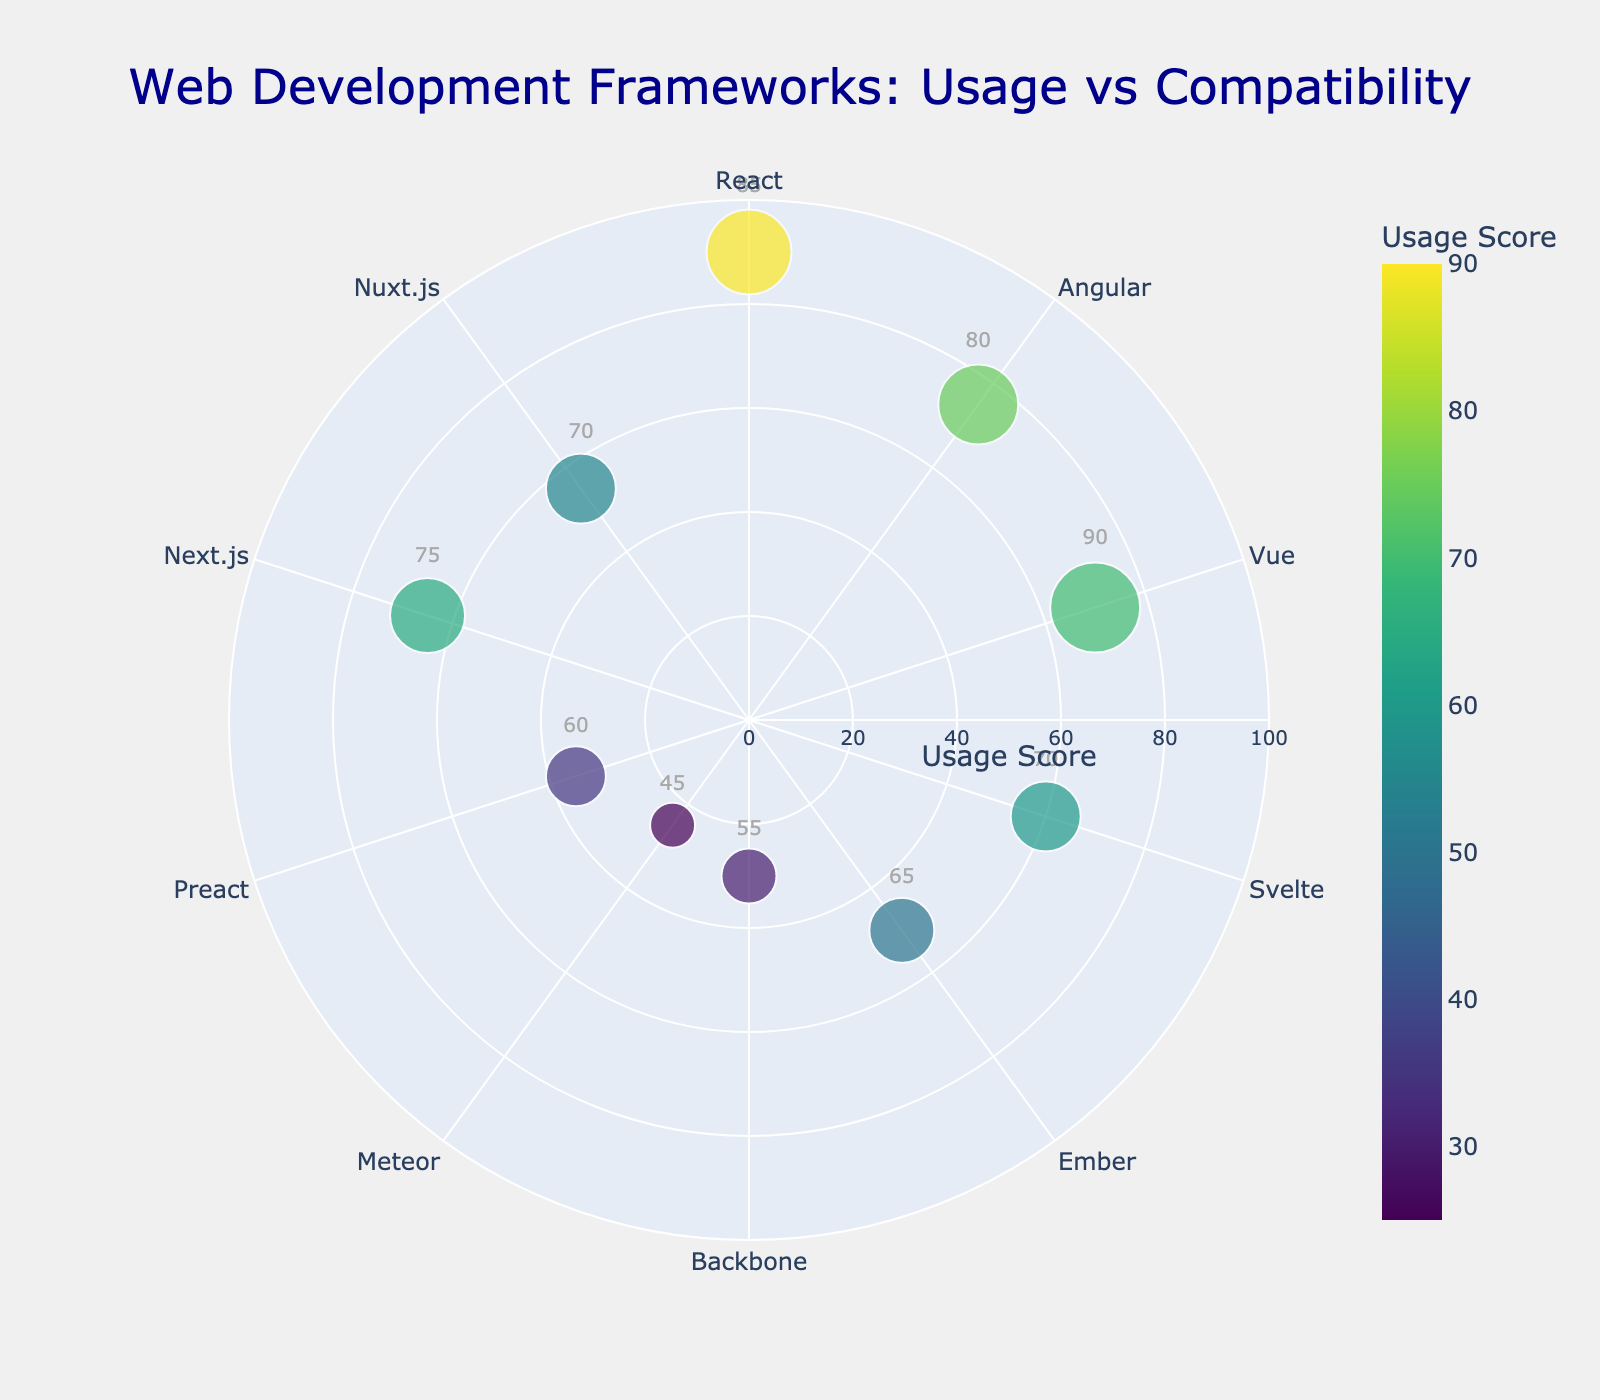Which framework has the highest usage score? The framework with the highest usage score is indicated by the largest marker size and the highest position on the radial axis. According to the data, React has the highest usage score of 90.
Answer: React What is the title of the figure? The title of the figure is usually displayed at the top of the plot. In this case, the title is given as "Web Development Frameworks: Usage vs Compatibility".
Answer: Web Development Frameworks: Usage vs Compatibility How many frameworks are represented in the plot? To determine the number of frameworks, count the number of data points or markers on the plot. Based on the data provided, there are 10 frameworks.
Answer: 10 Which framework has the lowest compatibility score? The framework with the lowest compatibility score will have the smallest marker size. According to the data, Meteor has the lowest compatibility score of 45.
Answer: Meteor What is the relationship between the usage score and the size of the markers? The size of the markers is proportional to the compatibility scores of the frameworks. Higher compatibility scores result in larger markers.
Answer: Larger markers correspond to higher compatibility Which framework is positioned closest to the 70 usage score on the radial axis? Locate the framework whose marker is positioned closest to the 70 usage score on the radial axis. According to the data, this framework is Vue with a usage score of 70.
Answer: Vue Compare the compatibility scores of Angular and Backbone. Which is higher? Look at the marker sizes for Angular and Backbone. Angular has a compatibility score of 80, and Backbone has a compatibility score of 55.
Answer: Angular Find the difference in usage scores between the framework with the highest score and the framework with the lowest score. The framework with the highest usage score is React (90), and the framework with the lowest score is Meteor (25). The difference is 90 - 25 = 65.
Answer: 65 What is the color range used in the plot, and what does it represent? The color range is shown via a color scale on the figure, representing various shades in the Viridis colorscale from light to dark green/yellow. This colorscale corresponds to the usage scores.
Answer: Viridis colorscale representing usage scores Which framework has a usage score closest to the average usage score? First, calculate the average usage score: (90+75+70+60+50+30+25+35+65+55) / 10 = 55. The framework closest to this average is Nuxt.js with a usage score of 55.
Answer: Nuxt.js 